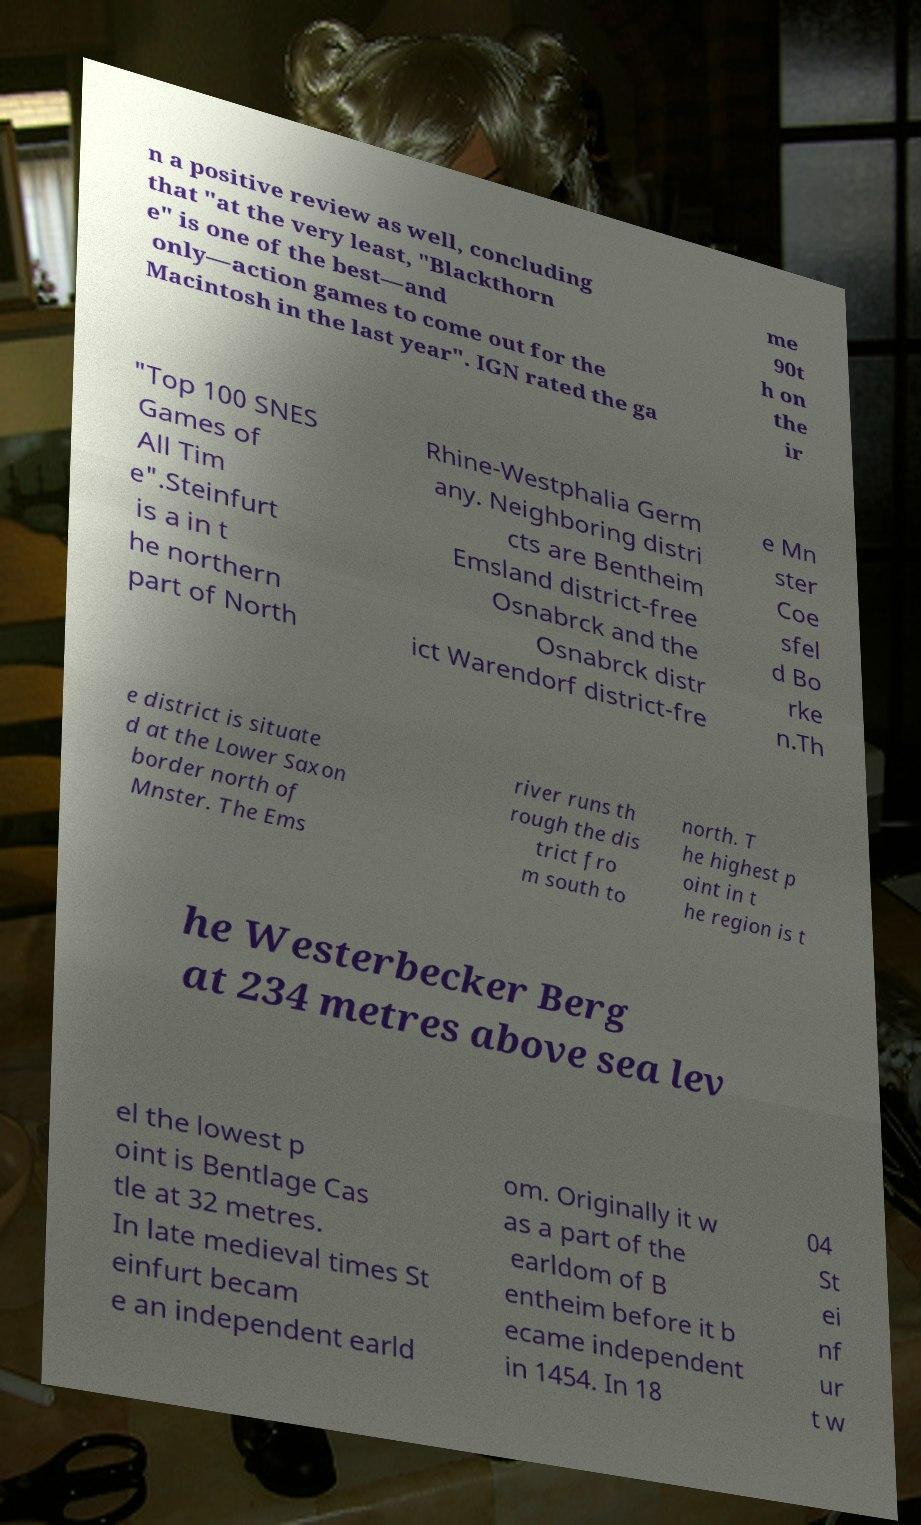There's text embedded in this image that I need extracted. Can you transcribe it verbatim? n a positive review as well, concluding that "at the very least, "Blackthorn e" is one of the best—and only—action games to come out for the Macintosh in the last year". IGN rated the ga me 90t h on the ir "Top 100 SNES Games of All Tim e".Steinfurt is a in t he northern part of North Rhine-Westphalia Germ any. Neighboring distri cts are Bentheim Emsland district-free Osnabrck and the Osnabrck distr ict Warendorf district-fre e Mn ster Coe sfel d Bo rke n.Th e district is situate d at the Lower Saxon border north of Mnster. The Ems river runs th rough the dis trict fro m south to north. T he highest p oint in t he region is t he Westerbecker Berg at 234 metres above sea lev el the lowest p oint is Bentlage Cas tle at 32 metres. In late medieval times St einfurt becam e an independent earld om. Originally it w as a part of the earldom of B entheim before it b ecame independent in 1454. In 18 04 St ei nf ur t w 